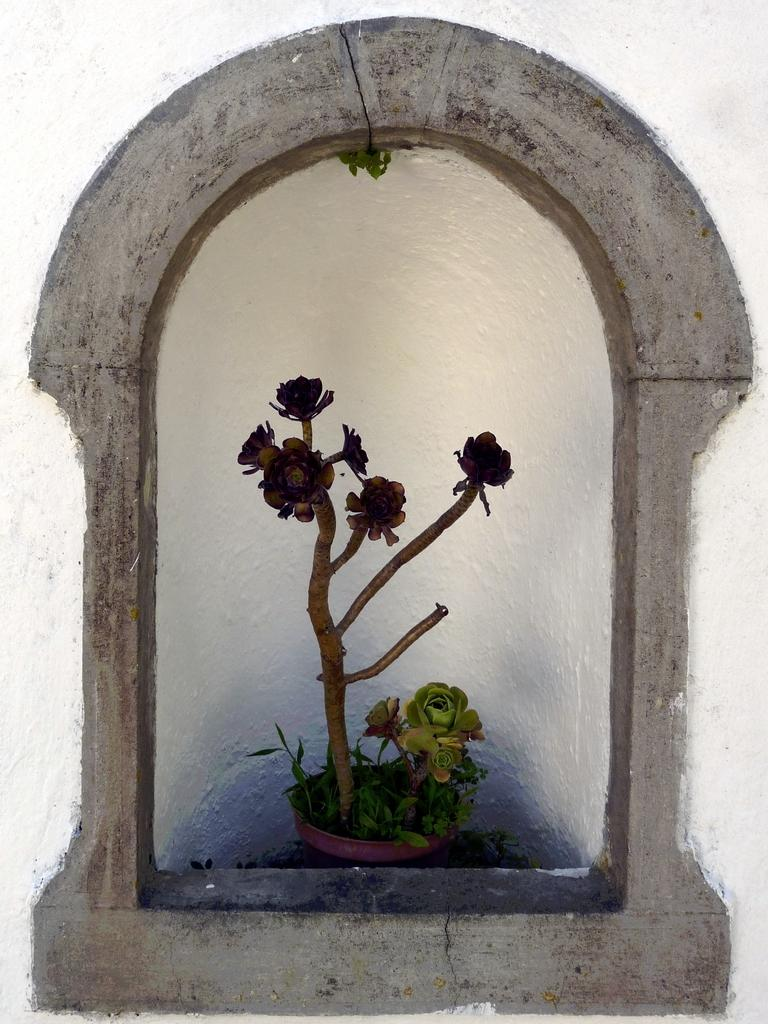What is the main subject of the painting in the image? The main subject of the painting is a cornerstone. What can be seen in the center of the painting? There is a flower pot in the center of the painting. What is inside the flower pot? There are plants in the flower pot. Are there any flowers visible in the painting? Yes, there are flowers in the center of the painting. How many chickens are present in the painting? There are no chickens present in the painting; it features a cornerstone, a flower pot, plants, and flowers. What type of war is depicted in the painting? There is no war depicted in the painting; it is a painting of a cornerstone with a flower pot, plants, and flowers. 